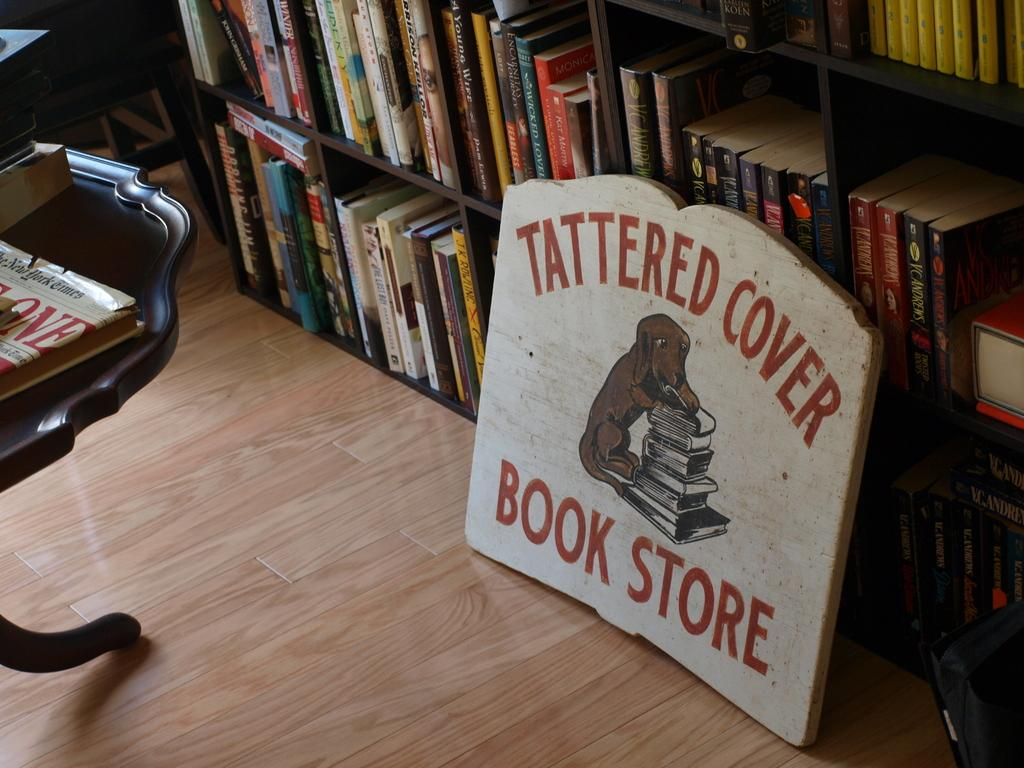<image>
Describe the image concisely. A sign that says Tattered Cover Book Store with a dog on it leaning up against a bookshelf. 